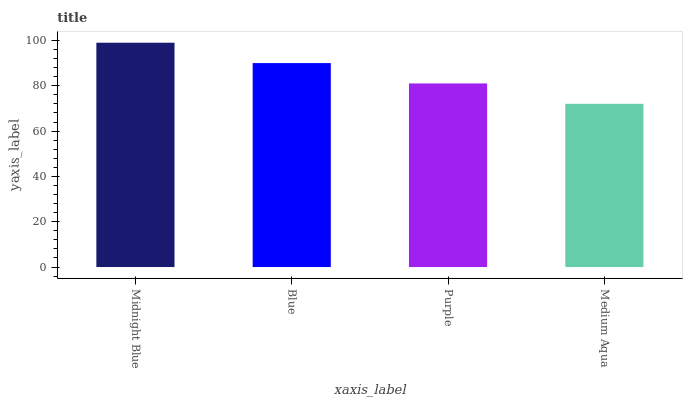Is Blue the minimum?
Answer yes or no. No. Is Blue the maximum?
Answer yes or no. No. Is Midnight Blue greater than Blue?
Answer yes or no. Yes. Is Blue less than Midnight Blue?
Answer yes or no. Yes. Is Blue greater than Midnight Blue?
Answer yes or no. No. Is Midnight Blue less than Blue?
Answer yes or no. No. Is Blue the high median?
Answer yes or no. Yes. Is Purple the low median?
Answer yes or no. Yes. Is Midnight Blue the high median?
Answer yes or no. No. Is Medium Aqua the low median?
Answer yes or no. No. 